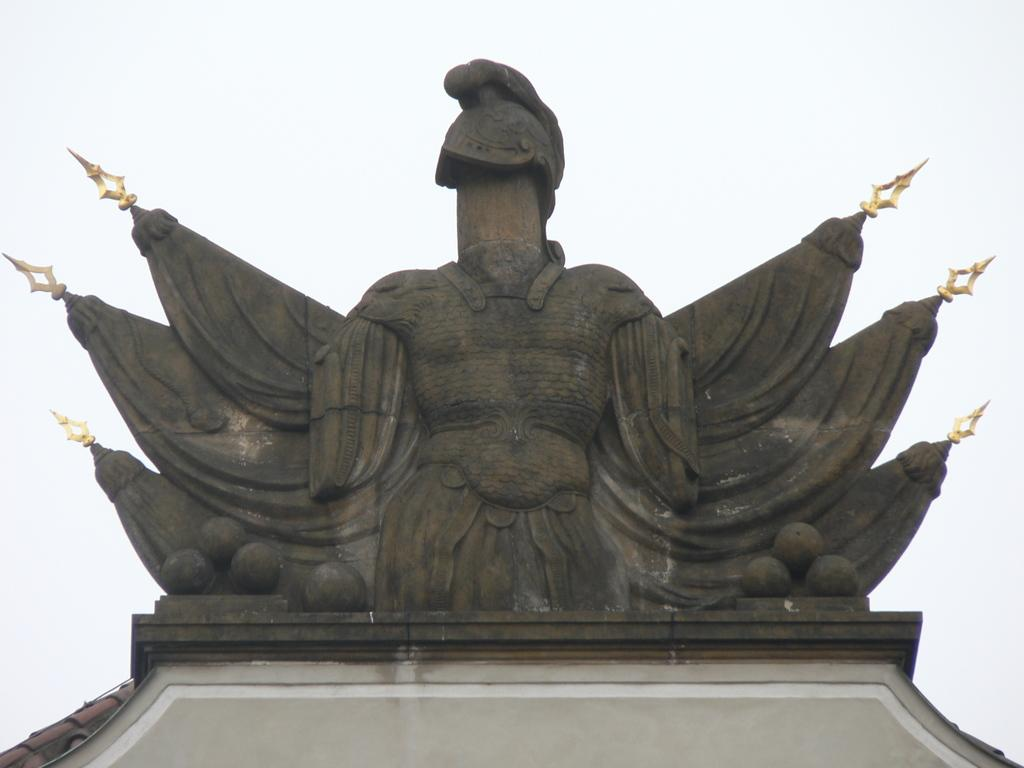What is the main subject of the image? The main subject of the image is a statue. Where is the statue located? The statue is present on an arch. What type of yarn is being used to decorate the hill in the image? There is no hill or yarn present in the image; it features a statue on an arch. What company is responsible for maintaining the statue in the image? The provided facts do not mention any company responsible for maintaining the statue, so we cannot answer this question. 